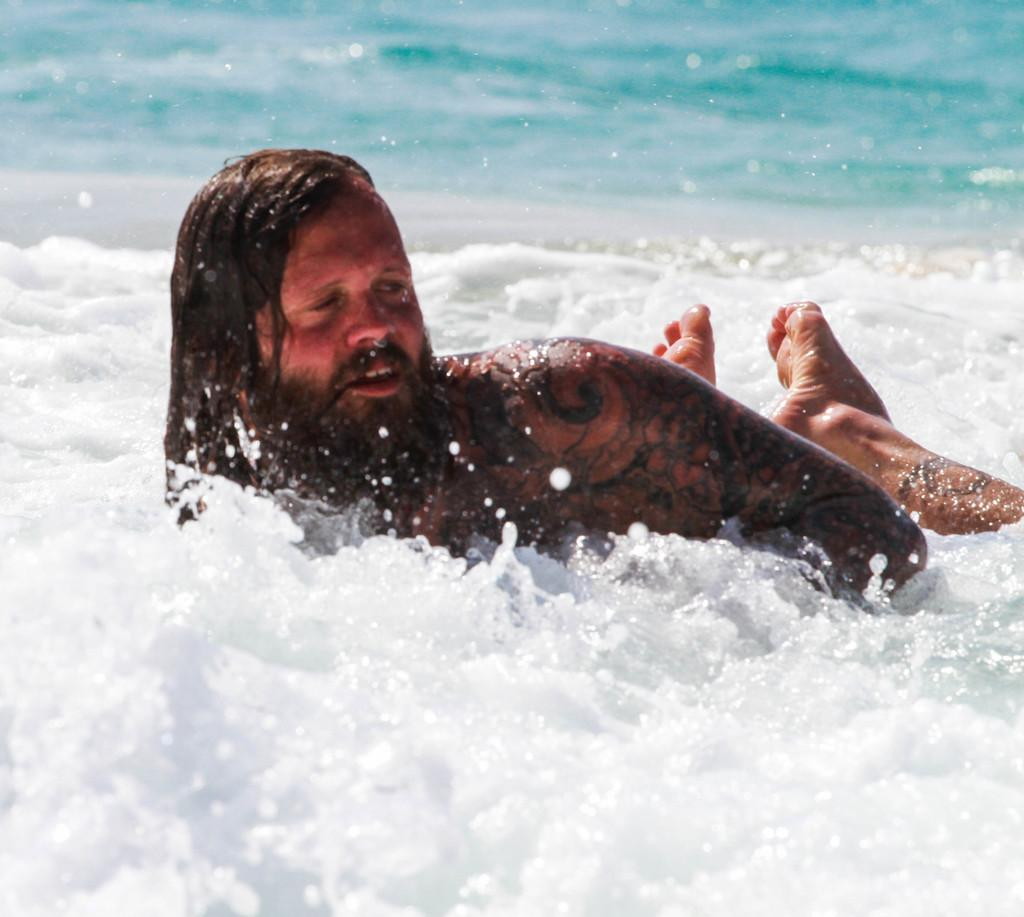What is happening in the image? There is a person in the image, and they are swimming in the water. Can you describe the person's activity in more detail? The person is swimming, which involves moving through the water using their arms and legs. What is the reason the writer is swimming in the sea in the image? There is no writer or sea present in the image; it only shows a person swimming in the water. 